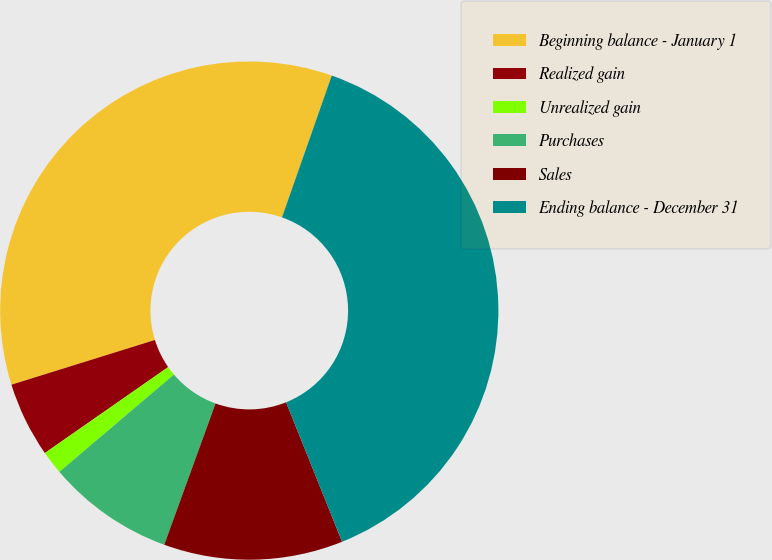Convert chart to OTSL. <chart><loc_0><loc_0><loc_500><loc_500><pie_chart><fcel>Beginning balance - January 1<fcel>Realized gain<fcel>Unrealized gain<fcel>Purchases<fcel>Sales<fcel>Ending balance - December 31<nl><fcel>35.18%<fcel>4.88%<fcel>1.52%<fcel>8.25%<fcel>11.62%<fcel>38.55%<nl></chart> 